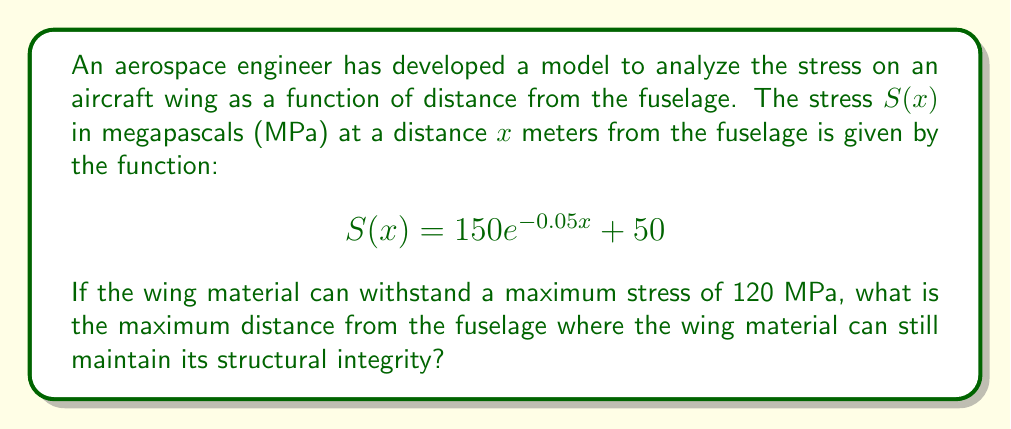Provide a solution to this math problem. To solve this problem, we need to follow these steps:

1) We're looking for the point where the stress equals 120 MPa. So, we need to solve the equation:

   $$120 = 150e^{-0.05x} + 50$$

2) Subtract 50 from both sides:

   $$70 = 150e^{-0.05x}$$

3) Divide both sides by 150:

   $$\frac{7}{15} = e^{-0.05x}$$

4) Take the natural logarithm of both sides:

   $$\ln(\frac{7}{15}) = \ln(e^{-0.05x})$$

5) Simplify the right side using the properties of logarithms:

   $$\ln(\frac{7}{15}) = -0.05x$$

6) Divide both sides by -0.05:

   $$\frac{\ln(\frac{7}{15})}{-0.05} = x$$

7) Calculate the value:

   $$x \approx 15.35$$

Therefore, the maximum distance from the fuselage where the wing material can maintain its structural integrity is approximately 15.35 meters.
Answer: 15.35 meters 